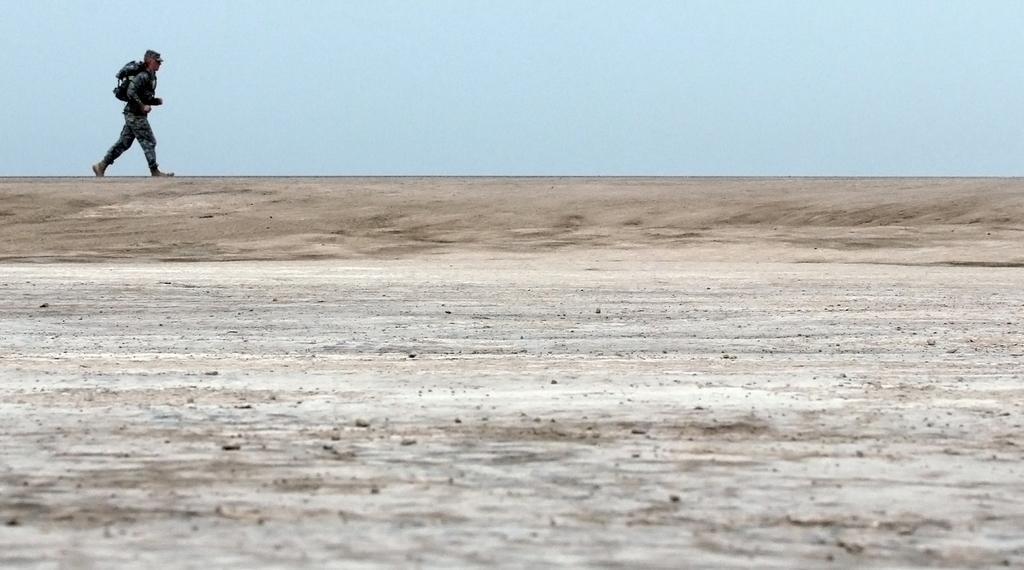Can you describe this image briefly? In this image we can see a soldier on the top left side and he is walking on the road. This is a clear sky. 